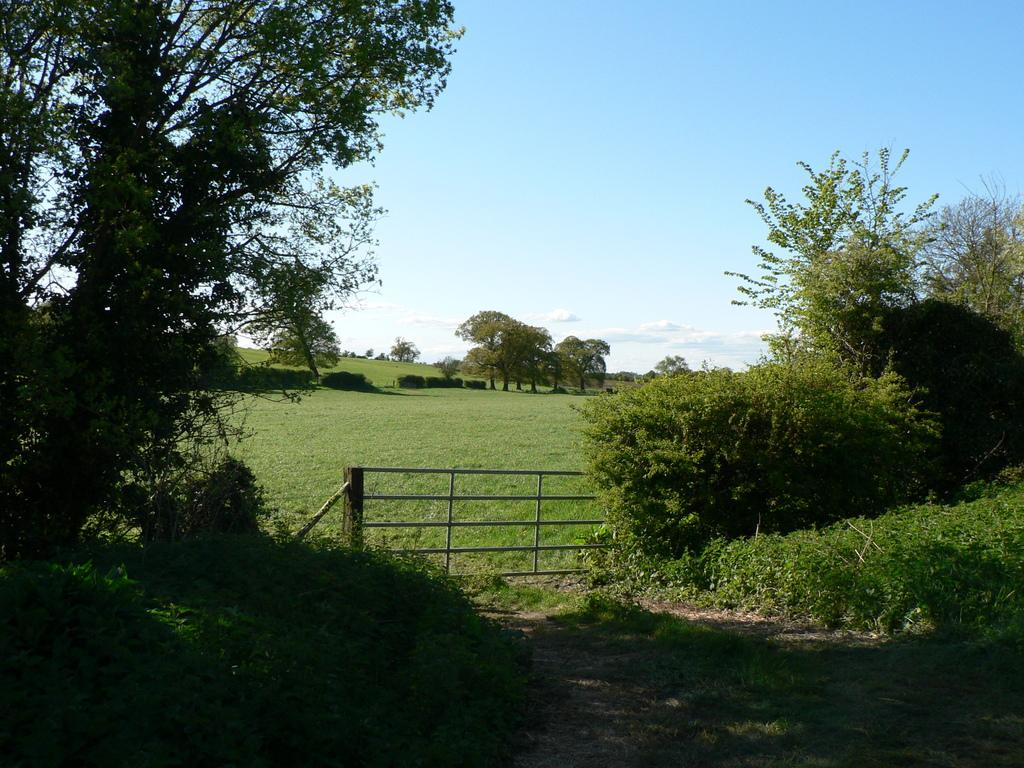What is located in the center of the image? There is a metal fence in the center of the image. What type of surface is visible at the bottom of the image? Grass is present on the surface at the bottom of the image. What can be seen in the background of the image? There are trees and the sky visible in the background of the image. What type of vest is hanging on the metal fence in the image? There is no vest present in the image; it only features a metal fence, grass, trees, and the sky. 